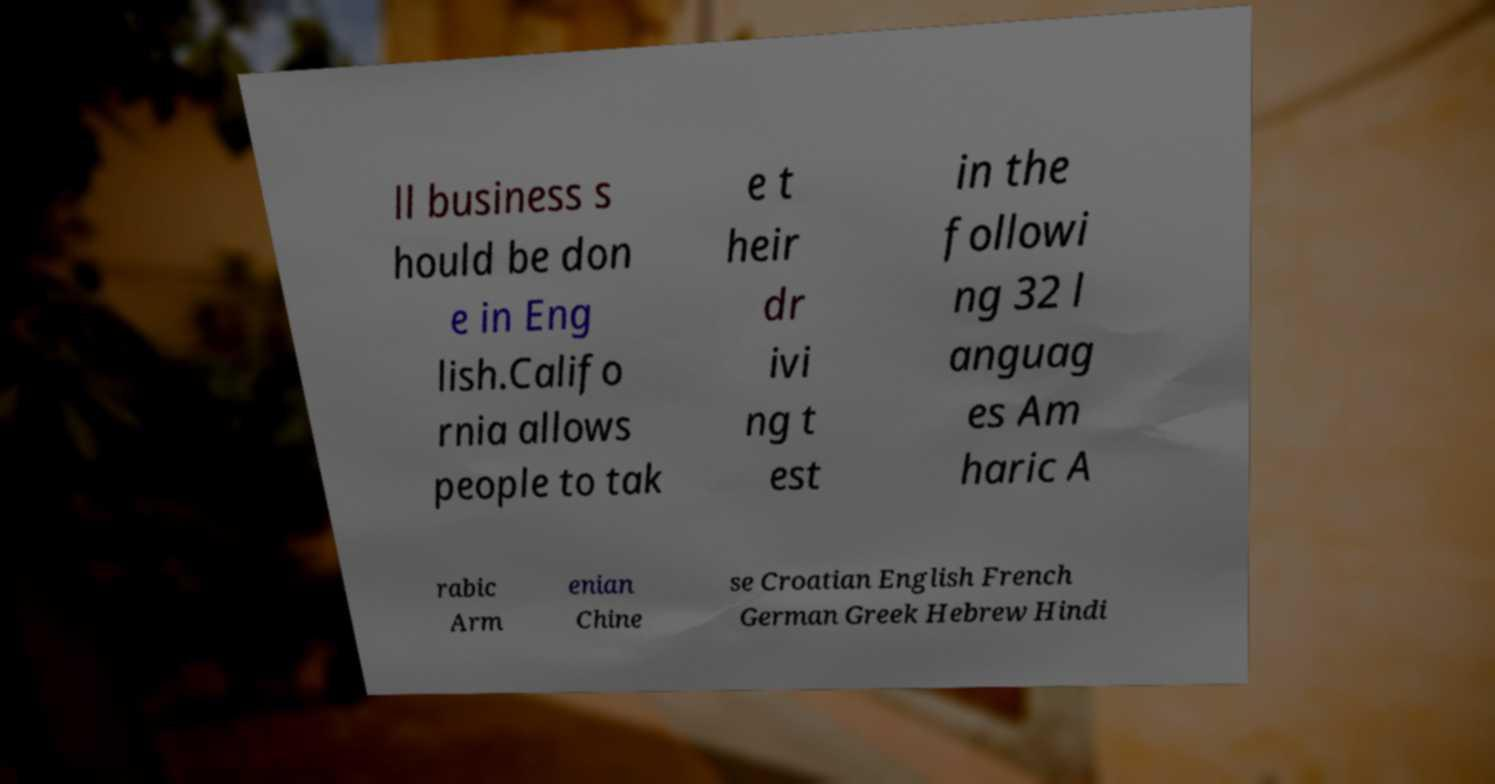Could you assist in decoding the text presented in this image and type it out clearly? ll business s hould be don e in Eng lish.Califo rnia allows people to tak e t heir dr ivi ng t est in the followi ng 32 l anguag es Am haric A rabic Arm enian Chine se Croatian English French German Greek Hebrew Hindi 